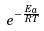<formula> <loc_0><loc_0><loc_500><loc_500>e ^ { - \frac { E _ { a } } { R T } }</formula> 